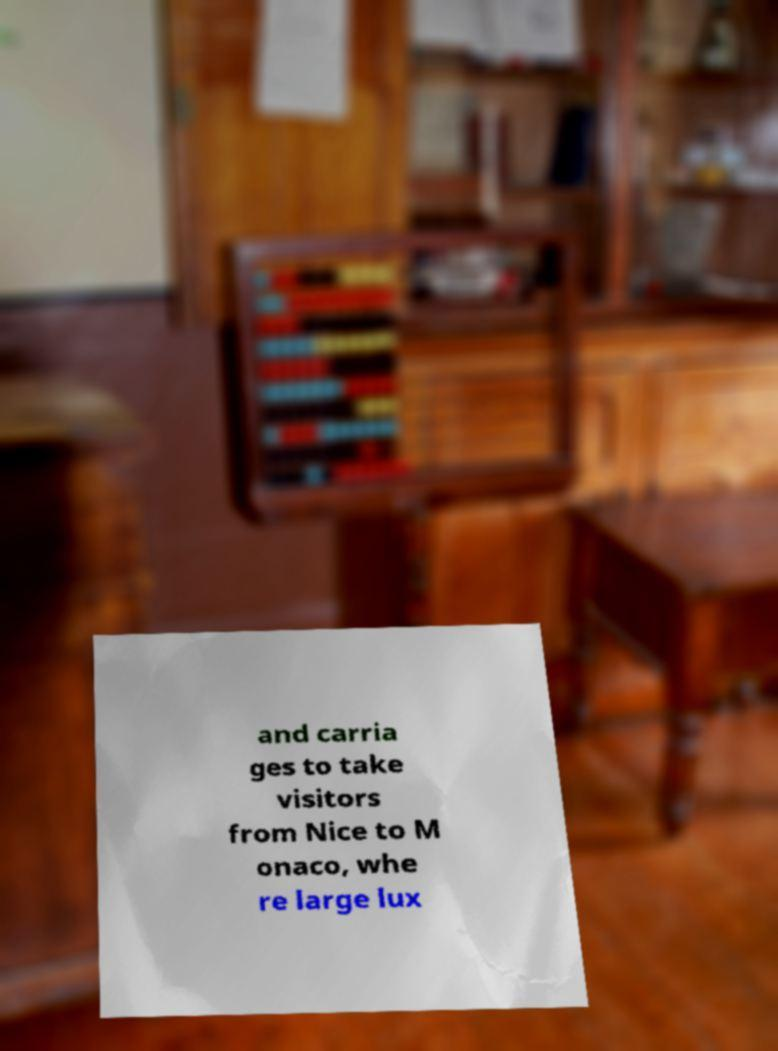What messages or text are displayed in this image? I need them in a readable, typed format. and carria ges to take visitors from Nice to M onaco, whe re large lux 